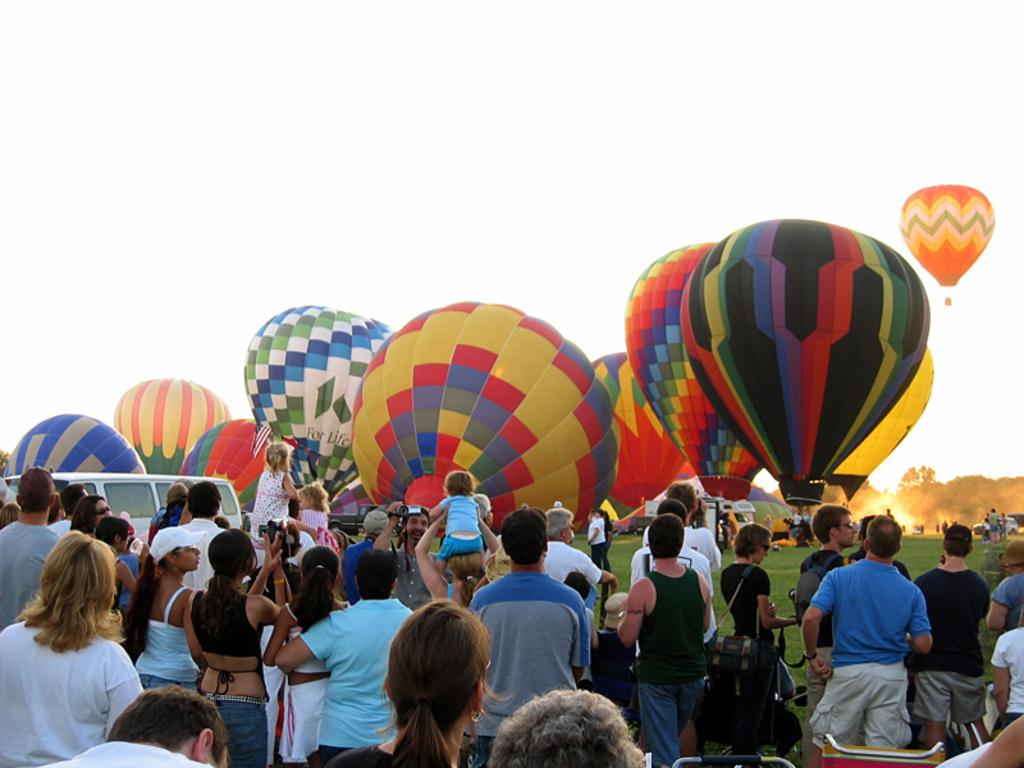Who or what can be seen in the image? There are people in the image. What are the people doing or interacting with in the image? They are near hot air balloons in the image. What type of natural environment is present in the image? There are trees and grass in the image. What mode of transportation is visible in the image? There is a vehicle in the image. What can be seen in the background of the image? The sky is visible in the background of the image. How many cows are grazing on the edge of the hole in the image? There are no cows or holes present in the image. 